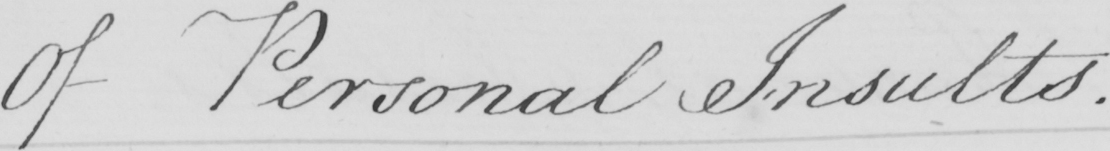What text is written in this handwritten line? Of Personal Insults . 